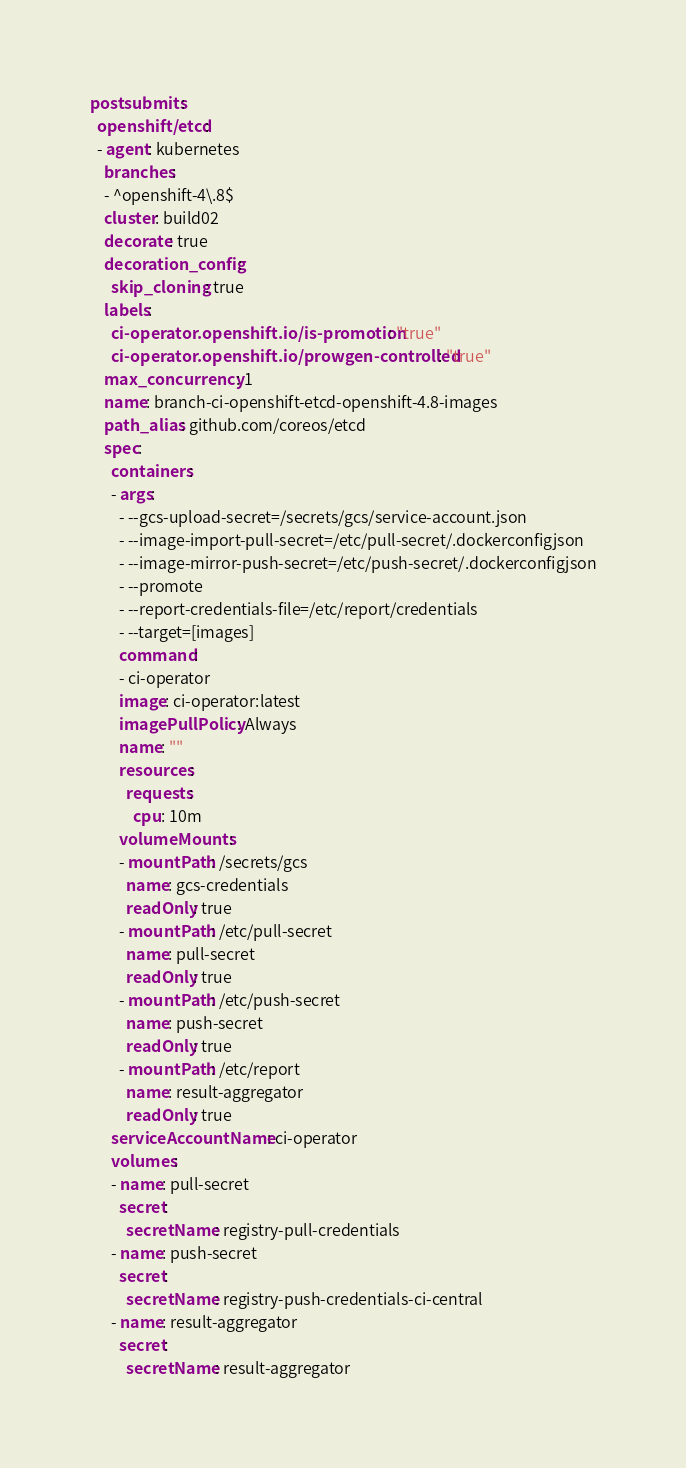Convert code to text. <code><loc_0><loc_0><loc_500><loc_500><_YAML_>postsubmits:
  openshift/etcd:
  - agent: kubernetes
    branches:
    - ^openshift-4\.8$
    cluster: build02
    decorate: true
    decoration_config:
      skip_cloning: true
    labels:
      ci-operator.openshift.io/is-promotion: "true"
      ci-operator.openshift.io/prowgen-controlled: "true"
    max_concurrency: 1
    name: branch-ci-openshift-etcd-openshift-4.8-images
    path_alias: github.com/coreos/etcd
    spec:
      containers:
      - args:
        - --gcs-upload-secret=/secrets/gcs/service-account.json
        - --image-import-pull-secret=/etc/pull-secret/.dockerconfigjson
        - --image-mirror-push-secret=/etc/push-secret/.dockerconfigjson
        - --promote
        - --report-credentials-file=/etc/report/credentials
        - --target=[images]
        command:
        - ci-operator
        image: ci-operator:latest
        imagePullPolicy: Always
        name: ""
        resources:
          requests:
            cpu: 10m
        volumeMounts:
        - mountPath: /secrets/gcs
          name: gcs-credentials
          readOnly: true
        - mountPath: /etc/pull-secret
          name: pull-secret
          readOnly: true
        - mountPath: /etc/push-secret
          name: push-secret
          readOnly: true
        - mountPath: /etc/report
          name: result-aggregator
          readOnly: true
      serviceAccountName: ci-operator
      volumes:
      - name: pull-secret
        secret:
          secretName: registry-pull-credentials
      - name: push-secret
        secret:
          secretName: registry-push-credentials-ci-central
      - name: result-aggregator
        secret:
          secretName: result-aggregator
</code> 